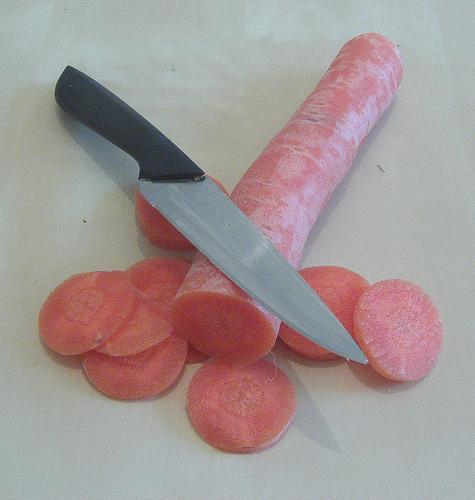How many carrot slices are there?
Give a very brief answer. 9. 